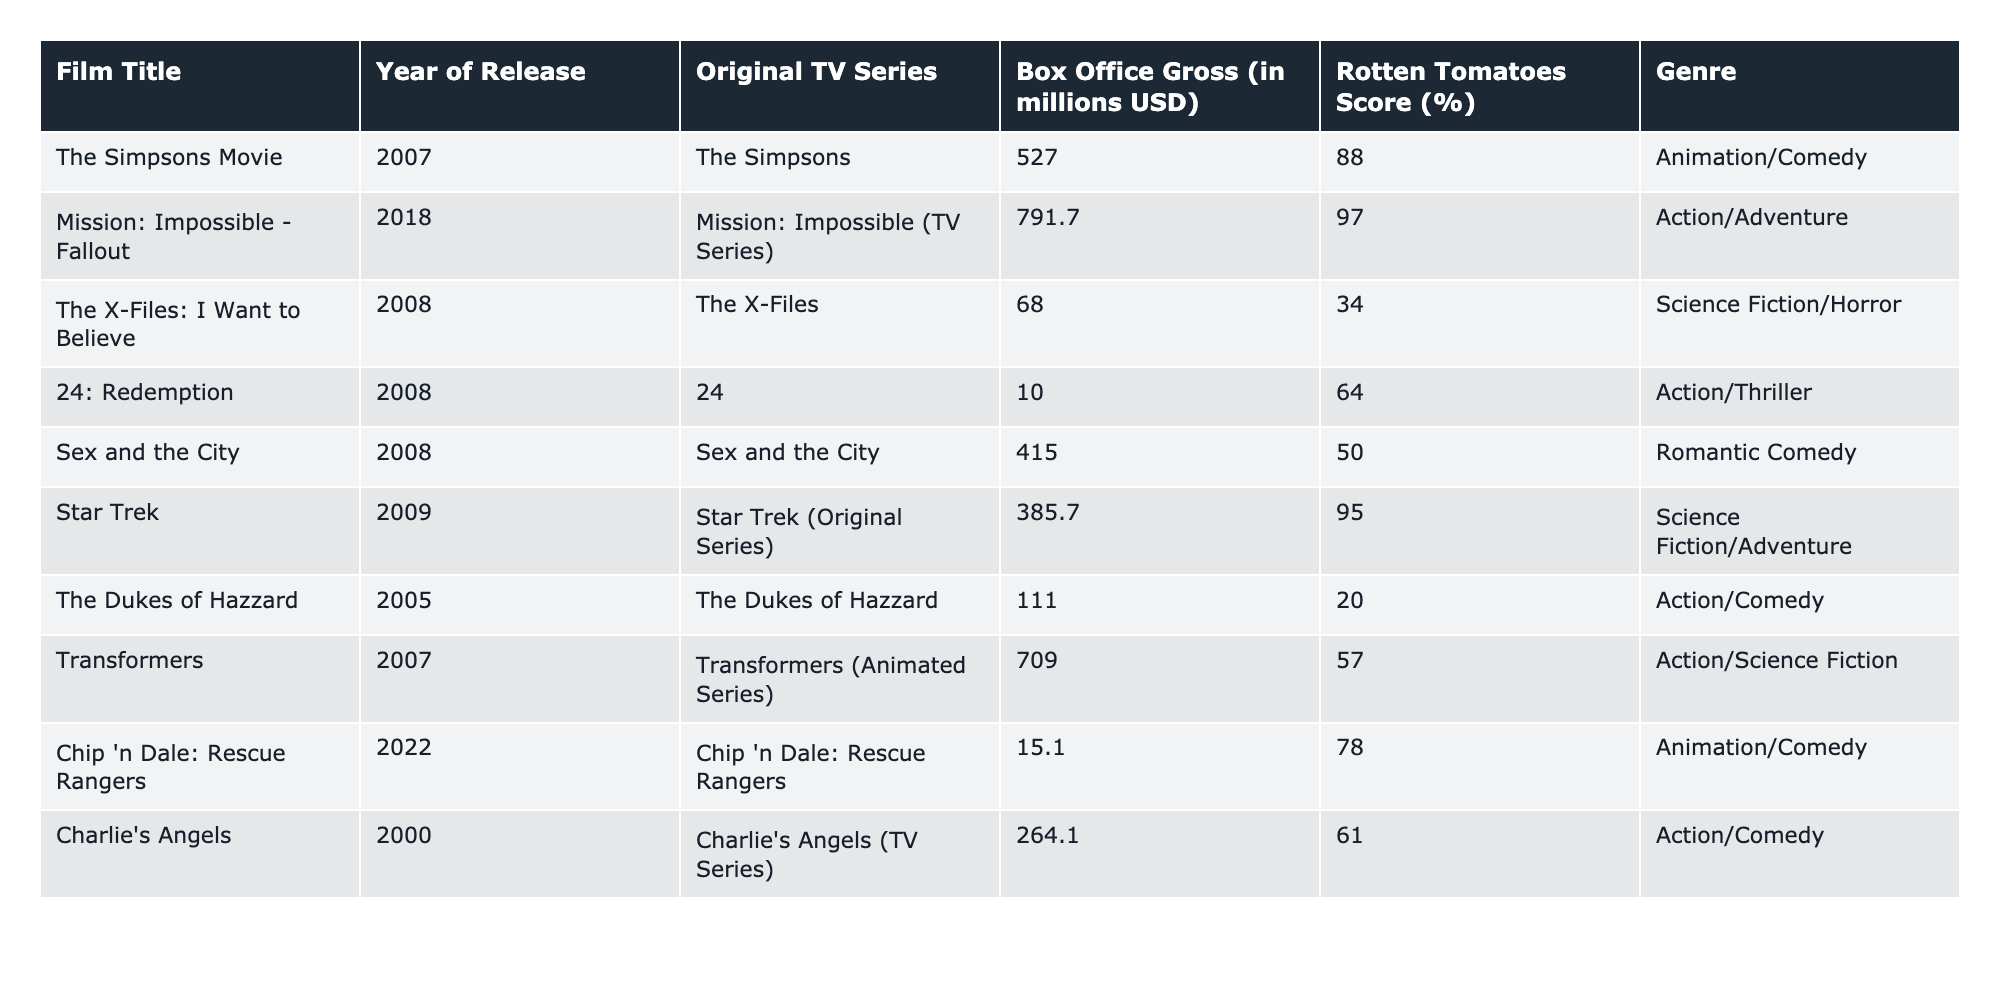What is the box office gross for "The Simpsons Movie"? The box office gross for "The Simpsons Movie" is listed directly under the "Box Office Gross (in millions USD)" column. It shows a value of 527.0 million USD.
Answer: 527.0 million USD Which film adaptation has the highest Rotten Tomatoes score? The Rotten Tomatoes scores for each film adaptation are compared, looking for the maximum value. "Mission: Impossible - Fallout" has the highest score of 97%.
Answer: Mission: Impossible - Fallout How much more did "Transformers" earn at the box office compared to "The Dukes of Hazzard"? The box office gross of "Transformers" is 709.0 million USD and "The Dukes of Hazzard" is 111.0 million USD. Subtracting these gives 709.0 - 111.0 = 598.0 million USD more for "Transformers."
Answer: 598.0 million USD What is the average box office gross of films with a Rotten Tomatoes score below 50%? First, identify the films with a score below 50%. These are "The X-Files: I Want to Believe" (68.0 million USD) and "The Dukes of Hazzard" (111.0 million USD) with a total of 68.0 + 111.0 = 179.0 million USD. There are 2 films, so the average is 179.0 / 2 = 89.5 million USD.
Answer: 89.5 million USD Is "Sex and the City" the only romantic comedy adaptation listed? By reviewing the genre of each film, "Sex and the City" is the only one classified as a "Romantic Comedy.”
Answer: Yes Which film adaptation released after 2005 has the lowest box office gross? The films released after 2005 can be identified: "Transformers" (2007), "The Simpsons Movie" (2007), "The X-Files: I Want to Believe" (2008), "24: Redemption" (2008), "Sex and the City" (2008), "Chip 'n Dale: Rescue Rangers" (2022), and comparing the box office grosses shows "Chip 'n Dale: Rescue Rangers" at 15.1 million USD is the lowest.
Answer: Chip 'n Dale: Rescue Rangers What percentage of films adapted from TV series had a box office gross of over 500 million USD? Total films adapted from TV series are counted: there are 10. The films with gross over 500 million USD are "The Simpsons Movie" (527.0 million USD), "Mission: Impossible - Fallout" (791.7 million USD), and "Transformers" (709.0 million USD), totaling 3 films. Therefore, the percentage is (3/10) * 100 = 30%.
Answer: 30% Which two genres have films that earned less than 100 million USD at the box office? Films with earnings less than 100 million USD include "24: Redemption" (10.0 million USD) and "Chip 'n Dale: Rescue Rangers" (15.1 million USD). The genres of these films are checked: "Action/Thriller" for "24: Redemption" and "Animation/Comedy" for "Chip 'n Dale: Rescue Rangers." Both genres apply.
Answer: Action/Thriller and Animation/Comedy What is the total box office gross for all the films in the table? The box office grosses are summed: 527.0 + 791.7 + 68.0 + 10.0 + 415.0 + 385.7 + 111.0 + 709.0 + 15.1 + 264.1 = 2867.6 million USD.
Answer: 2867.6 million USD 